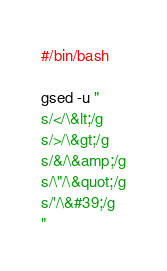<code> <loc_0><loc_0><loc_500><loc_500><_Bash_>#/bin/bash

gsed -u "
s/</\&lt;/g
s/>/\&gt;/g
s/&/\&amp;/g
s/\"/\&quot;/g
s/'/\&#39;/g
"</code> 